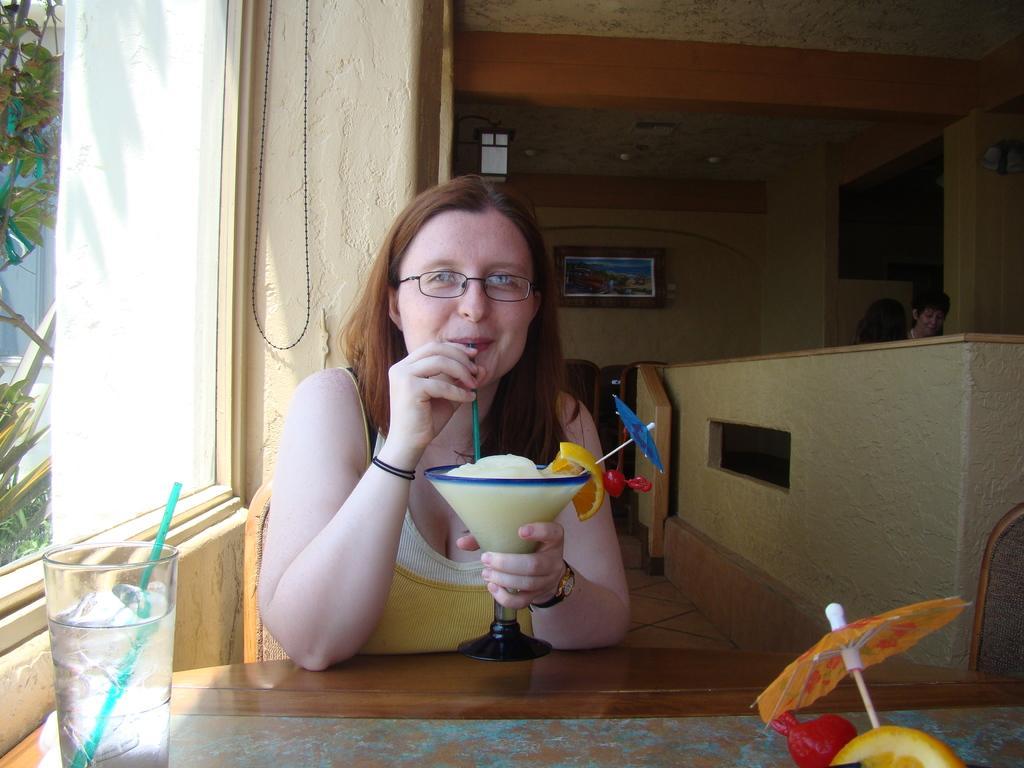Can you describe this image briefly? In the image there is a woman having soft drink sitting on chair in front of table with a glass on it, beside her there is a window, this is clicked in a restaurant. 